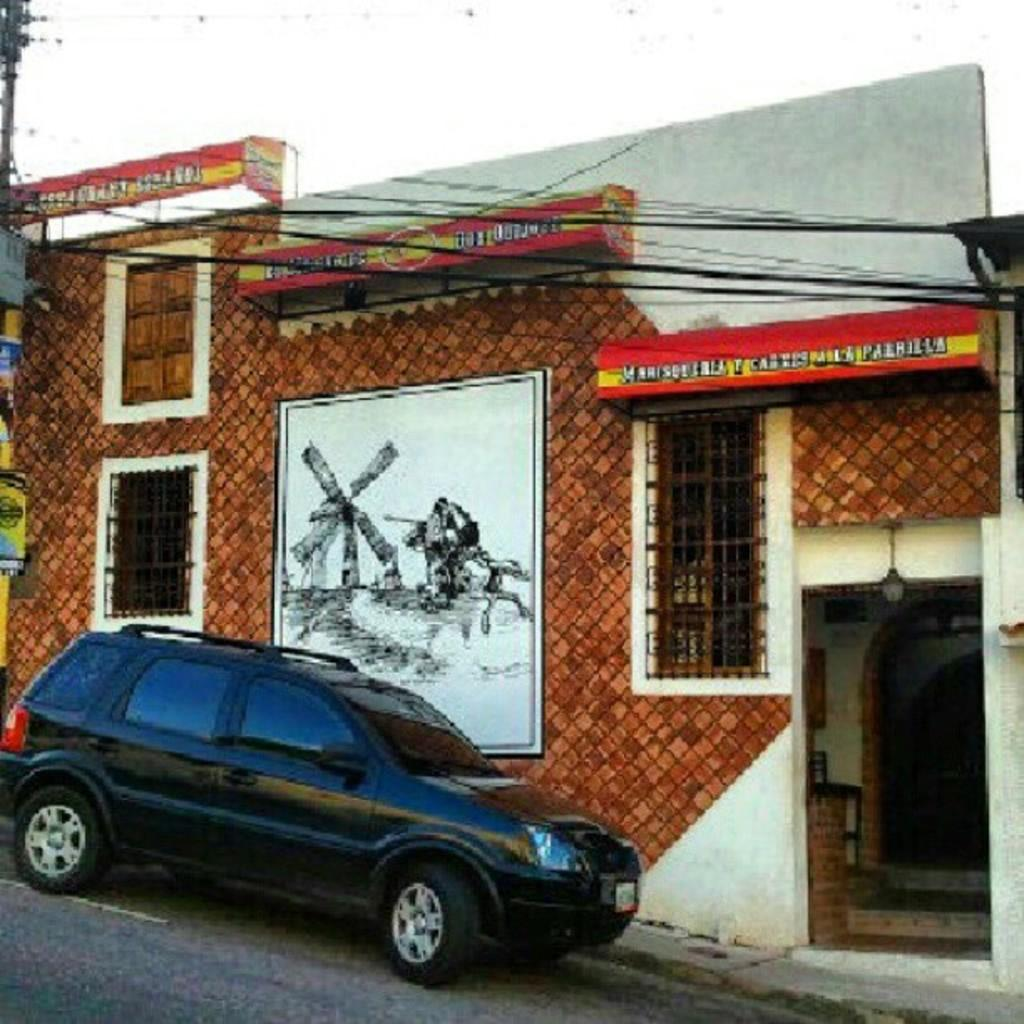What color is the car in the image? The car in the image is black. What can be seen in the background of the image? In the background of the image, there are wires, a pole, and a building. What is the color of the white thing in the image? The white thing in the image is white. Can you tell me how much profit the squirrel is making in the image? There is no squirrel present in the image, so it is not possible to determine any profit. 